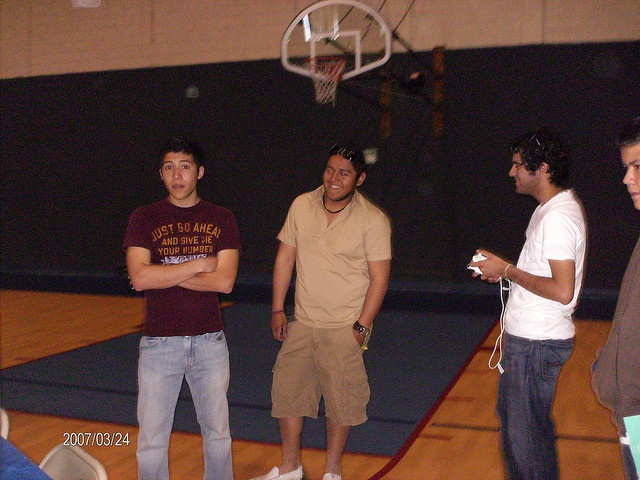Describe the objects in this image and their specific colors. I can see people in maroon, brown, and tan tones, people in maroon, darkgray, black, and brown tones, people in maroon, white, black, brown, and purple tones, people in maroon, gray, olive, brown, and black tones, and chair in maroon, gray, tan, and darkgray tones in this image. 